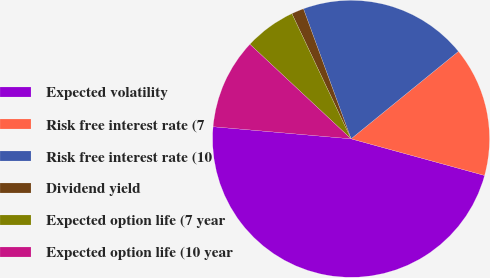<chart> <loc_0><loc_0><loc_500><loc_500><pie_chart><fcel>Expected volatility<fcel>Risk free interest rate (7<fcel>Risk free interest rate (10<fcel>Dividend yield<fcel>Expected option life (7 year<fcel>Expected option life (10 year<nl><fcel>47.13%<fcel>15.14%<fcel>19.71%<fcel>1.44%<fcel>6.01%<fcel>10.57%<nl></chart> 